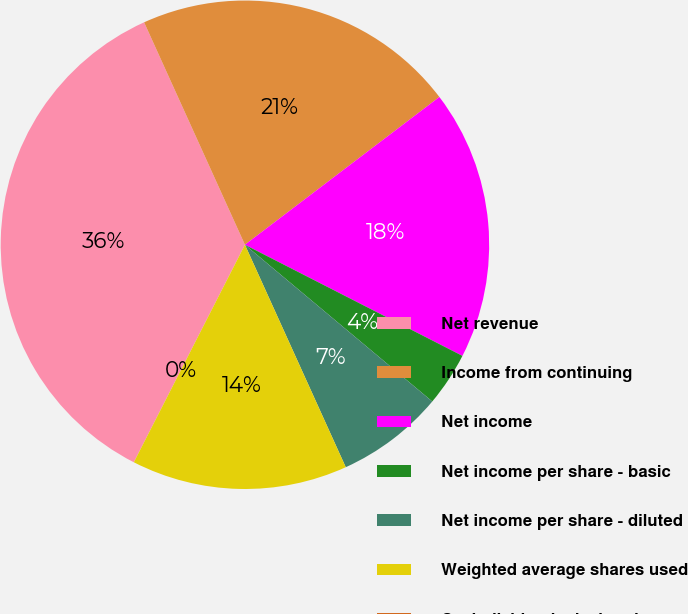Convert chart. <chart><loc_0><loc_0><loc_500><loc_500><pie_chart><fcel>Net revenue<fcel>Income from continuing<fcel>Net income<fcel>Net income per share - basic<fcel>Net income per share - diluted<fcel>Weighted average shares used<fcel>Cash dividends declared per<nl><fcel>35.71%<fcel>21.43%<fcel>17.86%<fcel>3.57%<fcel>7.14%<fcel>14.29%<fcel>0.0%<nl></chart> 